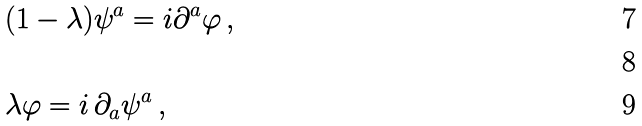<formula> <loc_0><loc_0><loc_500><loc_500>& ( 1 - \lambda ) \psi ^ { a } = i \partial ^ { a } \varphi \, , \\ & \\ & \lambda \varphi = i \, \partial _ { a } \psi ^ { a } \, ,</formula> 